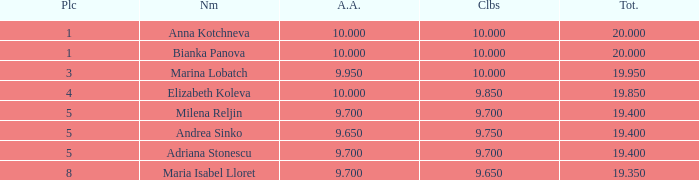What total has 10 as the clubs, with a place greater than 1? 19.95. 